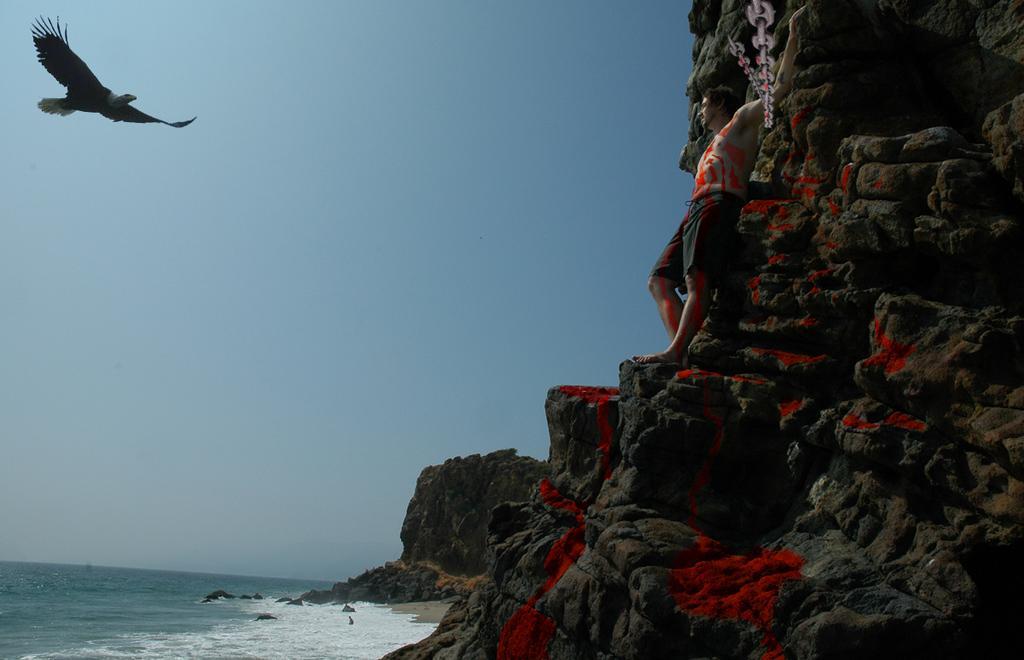Describe this image in one or two sentences. In this image on the right side there is a mountain, and there is one person standing. At the bottom there is a beach, and in the top left hand corner there is one bird and in the background there is sky. 